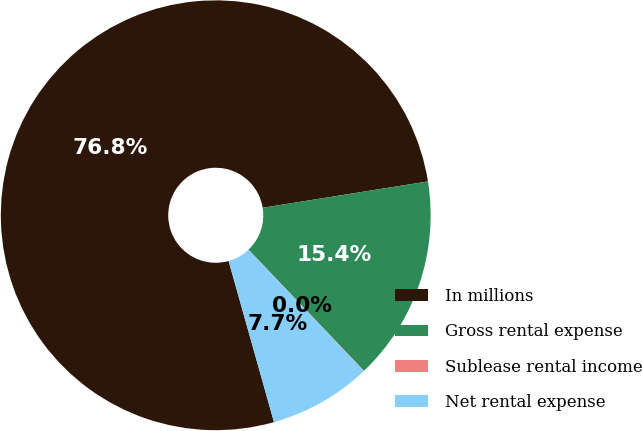Convert chart to OTSL. <chart><loc_0><loc_0><loc_500><loc_500><pie_chart><fcel>In millions<fcel>Gross rental expense<fcel>Sublease rental income<fcel>Net rental expense<nl><fcel>76.85%<fcel>15.4%<fcel>0.03%<fcel>7.72%<nl></chart> 